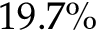<formula> <loc_0><loc_0><loc_500><loc_500>1 9 . 7 \%</formula> 